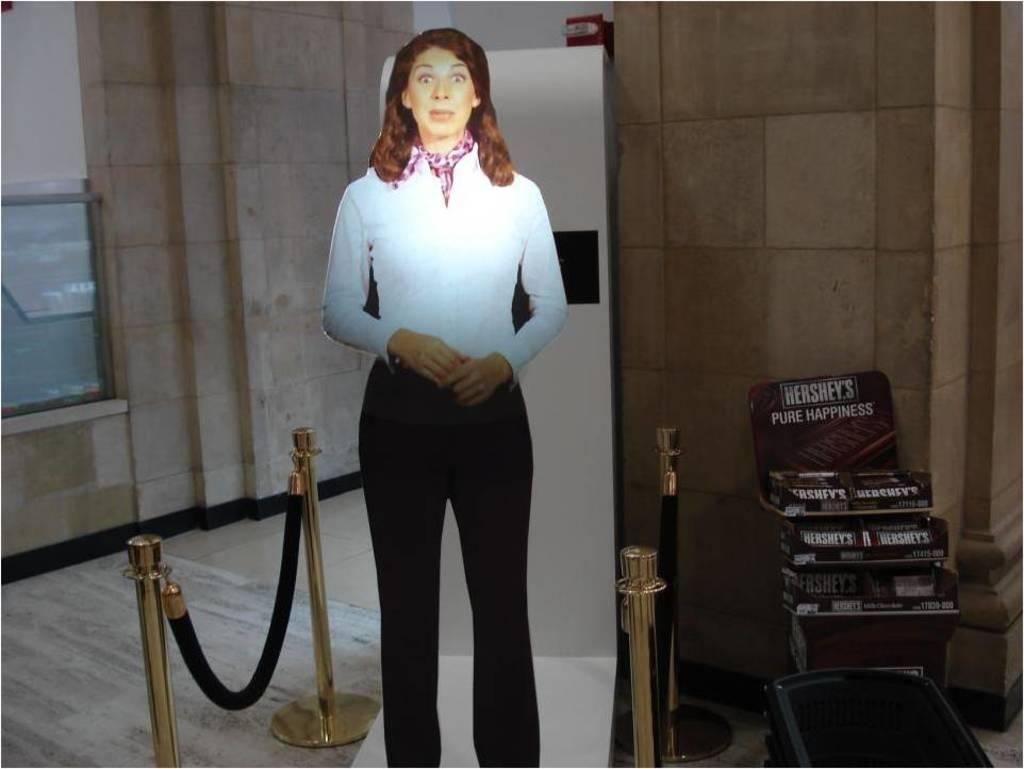<image>
Render a clear and concise summary of the photo. A suprised looking woman stands next to boxes of Hershey's chocolate bars. 